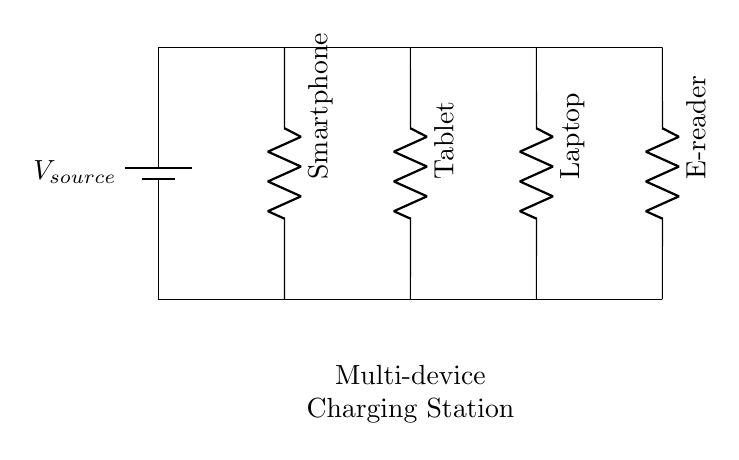What type of circuit is this? This is a parallel circuit, as indicated by multiple devices connected across the same voltage source. In a parallel configuration, each device is connected independently to the voltage source, allowing each to receive the full voltage.
Answer: Parallel How many devices are connected? There are four devices connected to the circuit: a smartphone, a tablet, a laptop, and an e-reader. Each is represented by a resistor in the diagram. Counting the resistors shows four devices.
Answer: Four What is the voltage supplied by the source? The voltage of the source is not explicitly stated in the diagram, but it is the same across all components due to the nature of a parallel circuit. Generally, it can be assumed to be a standard voltage, such as five volts for charging devices.
Answer: Assumed five volts Which device has the greatest voltage drop? In parallel circuits, the voltage drop across all components remains the same as the voltage of the source. Therefore, no device has a greater voltage drop than the others, as they all share the same source voltage.
Answer: None How do current flows differ among devices? In a parallel circuit, each device has its branch. The total current in the circuit is the sum of the currents through each device. Since current can vary based on the resistance of each device, devices can draw different amounts of current while still receiving the same voltage.
Answer: Varies by device What happens if one device fails? If one device fails in a parallel circuit, the other devices will continue to operate unaffected. This is a key advantage of parallel circuits compared to series circuits, where a failure in one component stops the entire circuit.
Answer: Others remain operational 